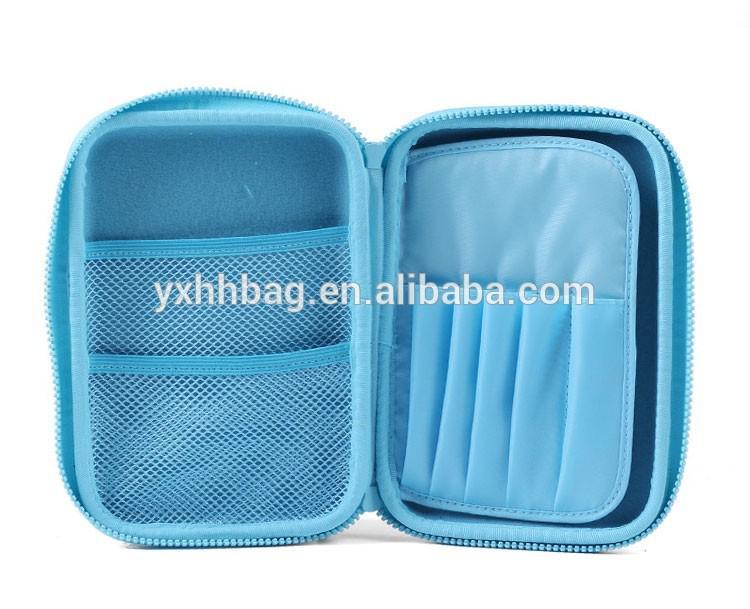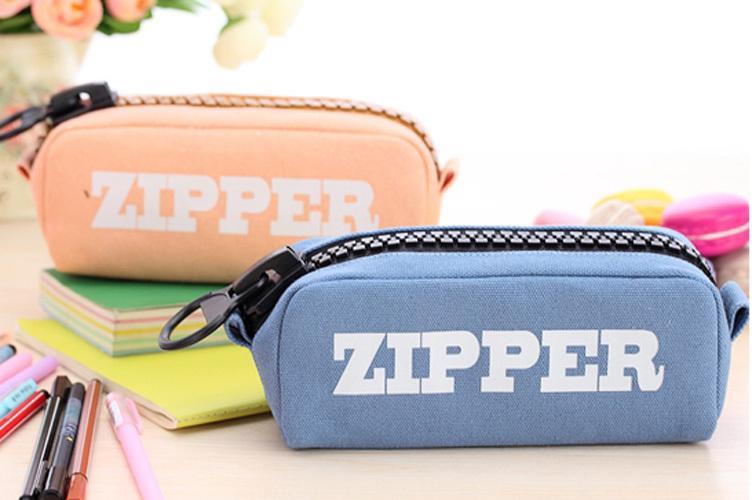The first image is the image on the left, the second image is the image on the right. Examine the images to the left and right. Is the description "At leat one container is green." accurate? Answer yes or no. No. 